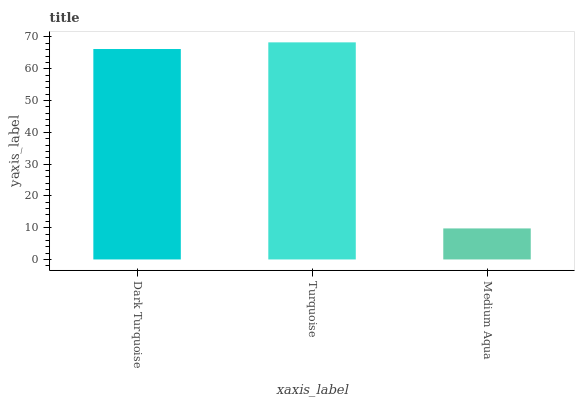Is Medium Aqua the minimum?
Answer yes or no. Yes. Is Turquoise the maximum?
Answer yes or no. Yes. Is Turquoise the minimum?
Answer yes or no. No. Is Medium Aqua the maximum?
Answer yes or no. No. Is Turquoise greater than Medium Aqua?
Answer yes or no. Yes. Is Medium Aqua less than Turquoise?
Answer yes or no. Yes. Is Medium Aqua greater than Turquoise?
Answer yes or no. No. Is Turquoise less than Medium Aqua?
Answer yes or no. No. Is Dark Turquoise the high median?
Answer yes or no. Yes. Is Dark Turquoise the low median?
Answer yes or no. Yes. Is Turquoise the high median?
Answer yes or no. No. Is Turquoise the low median?
Answer yes or no. No. 